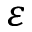Convert formula to latex. <formula><loc_0><loc_0><loc_500><loc_500>\varepsilon</formula> 